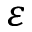Convert formula to latex. <formula><loc_0><loc_0><loc_500><loc_500>\varepsilon</formula> 